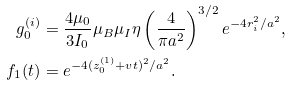<formula> <loc_0><loc_0><loc_500><loc_500>g _ { 0 } ^ { ( i ) } & = \frac { 4 \mu _ { 0 } } { 3 I _ { 0 } } \mu _ { B } \mu _ { I } \eta \left ( \frac { 4 } { \pi a ^ { 2 } } \right ) ^ { 3 / 2 } e ^ { - 4 r _ { i } ^ { 2 } / a ^ { 2 } } \text {,} \\ f _ { 1 } ( t ) & = e ^ { - 4 ( z _ { 0 } ^ { ( 1 ) } + v t ) ^ { 2 } / a ^ { 2 } } \text {.}</formula> 